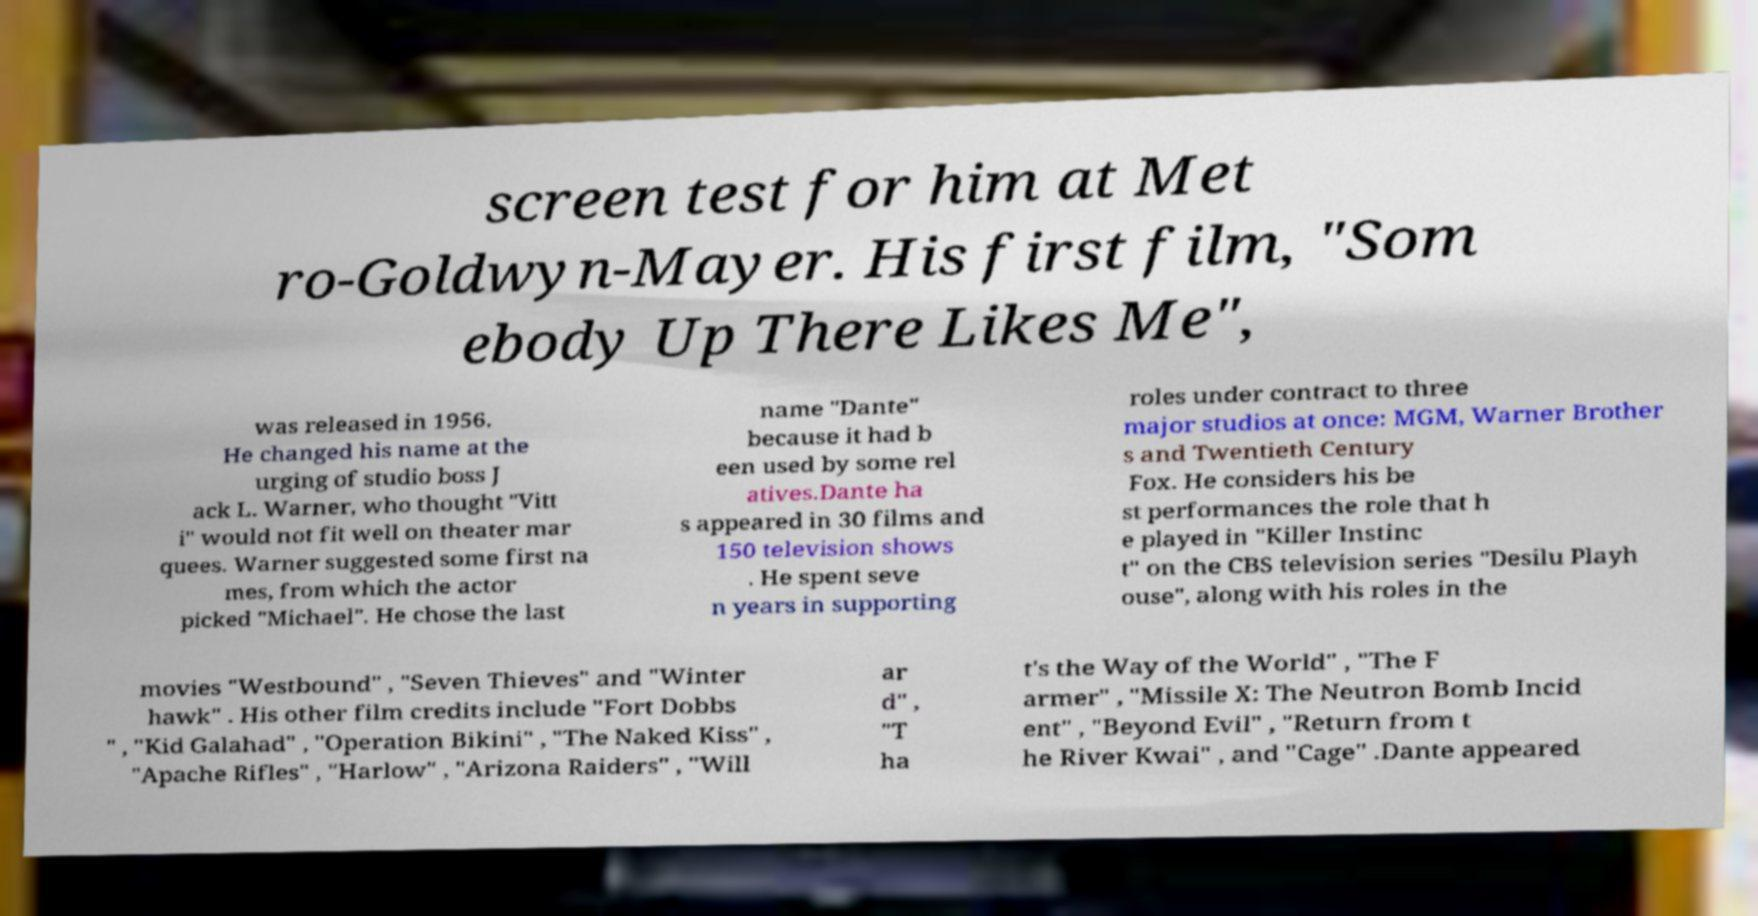For documentation purposes, I need the text within this image transcribed. Could you provide that? screen test for him at Met ro-Goldwyn-Mayer. His first film, "Som ebody Up There Likes Me", was released in 1956. He changed his name at the urging of studio boss J ack L. Warner, who thought "Vitt i" would not fit well on theater mar quees. Warner suggested some first na mes, from which the actor picked "Michael". He chose the last name "Dante" because it had b een used by some rel atives.Dante ha s appeared in 30 films and 150 television shows . He spent seve n years in supporting roles under contract to three major studios at once: MGM, Warner Brother s and Twentieth Century Fox. He considers his be st performances the role that h e played in "Killer Instinc t" on the CBS television series "Desilu Playh ouse", along with his roles in the movies "Westbound" , "Seven Thieves" and "Winter hawk" . His other film credits include "Fort Dobbs " , "Kid Galahad" , "Operation Bikini" , "The Naked Kiss" , "Apache Rifles" , "Harlow" , "Arizona Raiders" , "Will ar d" , "T ha t's the Way of the World" , "The F armer" , "Missile X: The Neutron Bomb Incid ent" , "Beyond Evil" , "Return from t he River Kwai" , and "Cage" .Dante appeared 